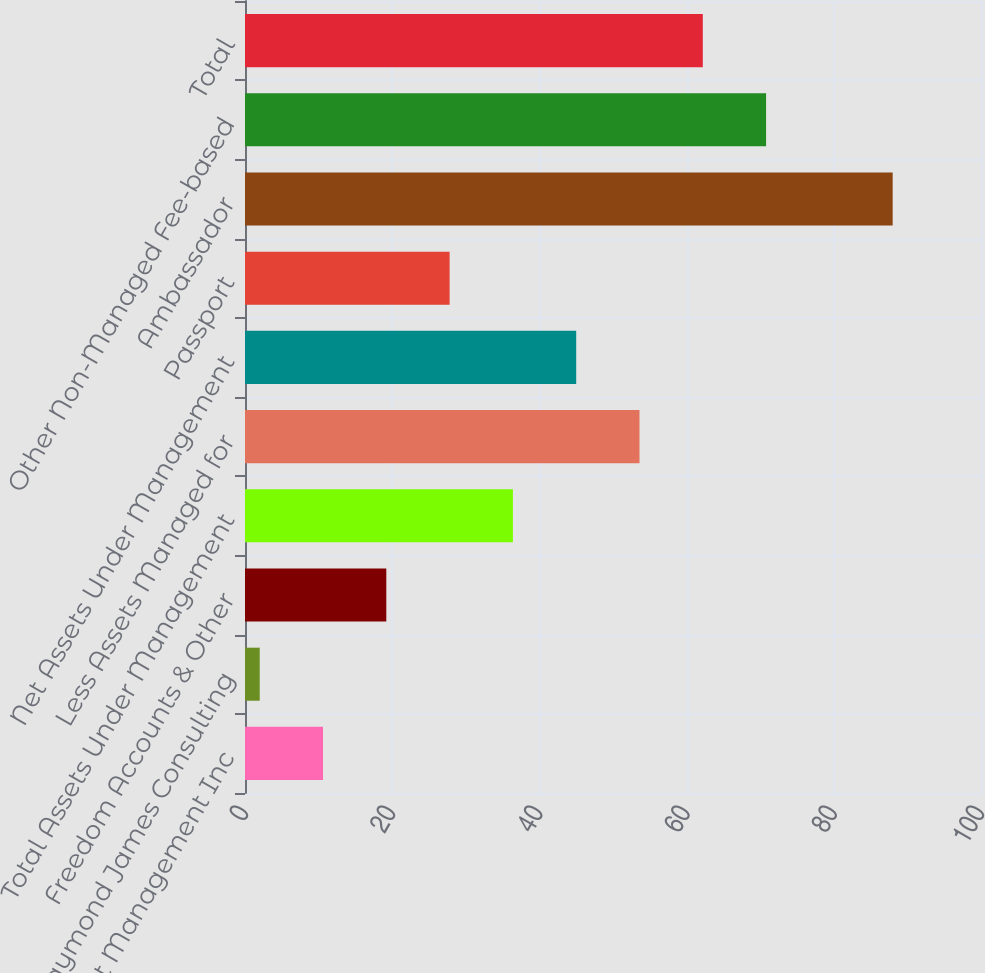Convert chart. <chart><loc_0><loc_0><loc_500><loc_500><bar_chart><fcel>Eagle Asset Management Inc<fcel>Raymond James Consulting<fcel>Freedom Accounts & Other<fcel>Total Assets Under Management<fcel>Less Assets Managed for<fcel>Net Assets Under Management<fcel>Passport<fcel>Ambassador<fcel>Other Non-Managed Fee-based<fcel>Total<nl><fcel>10.6<fcel>2<fcel>19.2<fcel>36.4<fcel>53.6<fcel>45<fcel>27.8<fcel>88<fcel>70.8<fcel>62.2<nl></chart> 